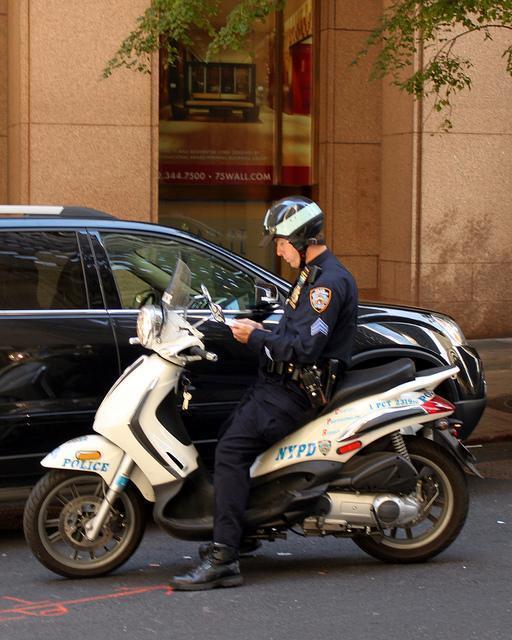Who is on the bicycle?
Choose the correct response, then elucidate: 'Answer: answer
Rationale: rationale.'
Options: Rodeo performer, police officer, actress, clown. Answer: police officer.
Rationale: An officer is on the bike. 